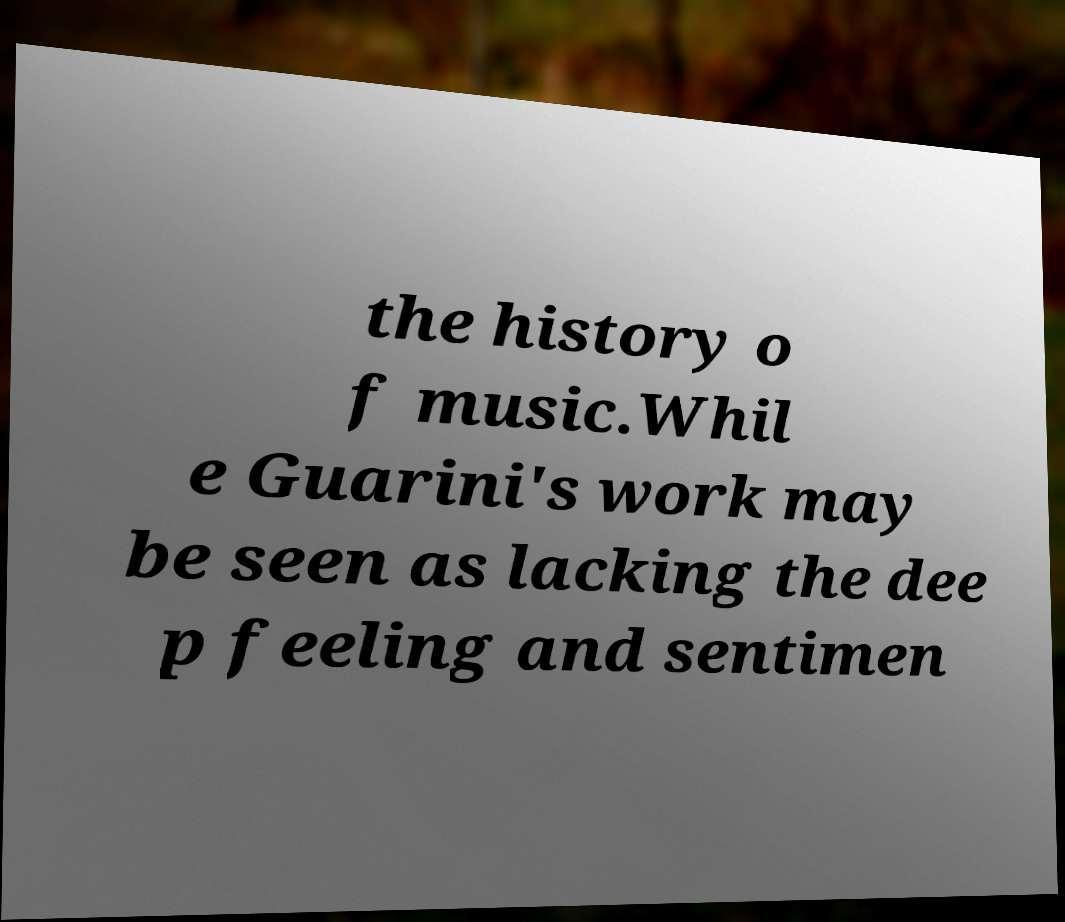What messages or text are displayed in this image? I need them in a readable, typed format. the history o f music.Whil e Guarini's work may be seen as lacking the dee p feeling and sentimen 